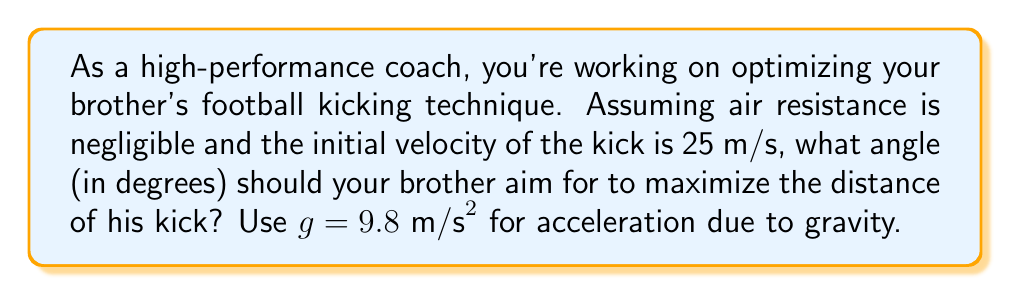What is the answer to this math problem? To solve this problem, we need to use the principles of projectile motion. The distance traveled by a projectile (in this case, the football) is given by the formula:

$$ d = \frac{v_0^2 \sin(2\theta)}{g} $$

Where:
$d$ is the distance traveled
$v_0$ is the initial velocity
$\theta$ is the angle of projection
$g$ is the acceleration due to gravity

To maximize the distance, we need to find the angle $\theta$ that gives the maximum value for $\sin(2\theta)$. 

The maximum value of sine function is 1, which occurs when its argument is 90°. Therefore:

$$ 2\theta = 90° $$
$$ \theta = 45° $$

We can verify this mathematically:

$$ \frac{d}{d\theta}(\sin(2\theta)) = 2\cos(2\theta) $$

Setting this equal to zero:

$$ 2\cos(2\theta) = 0 $$
$$ \cos(2\theta) = 0 $$

This occurs when $2\theta = 90°$ or $\theta = 45°$.

Therefore, to maximize the distance of the kick, your brother should aim for a 45° angle.

[asy]
import graph;
size(200,200);
real f(real x) {return -x^2/50+x;}
draw(graph(f,0,10));
draw((0,0)--(10,0),arrow=Arrow(TeXHead));
draw((0,0)--(0,5),arrow=Arrow(TeXHead));
label("Distance",(-0.5,5),W);
label("Angle",(10,-0.5),S);
label("45°",(5,-0.5),N);
draw((5,0)--(5,f(5)),dashed);
[/asy]
Answer: 45° 